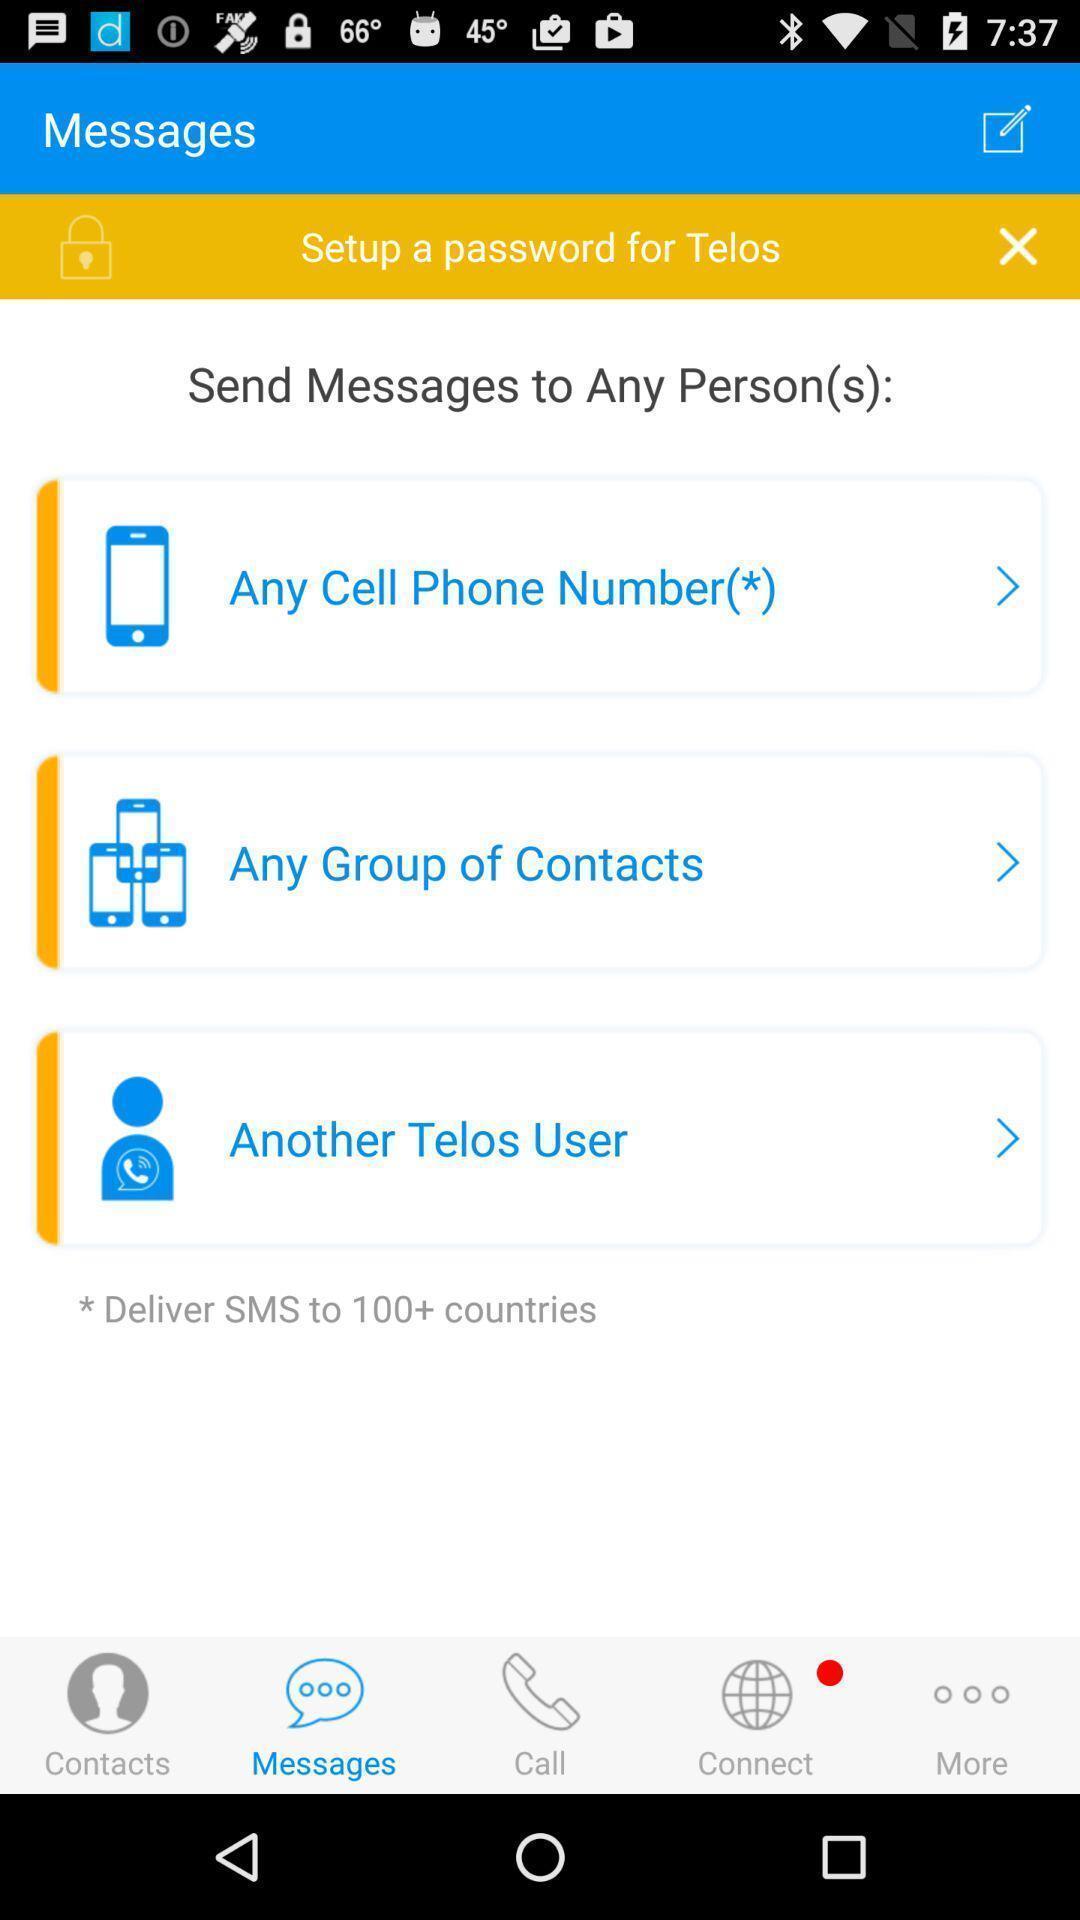Give me a narrative description of this picture. Page showing information from a calling app. 